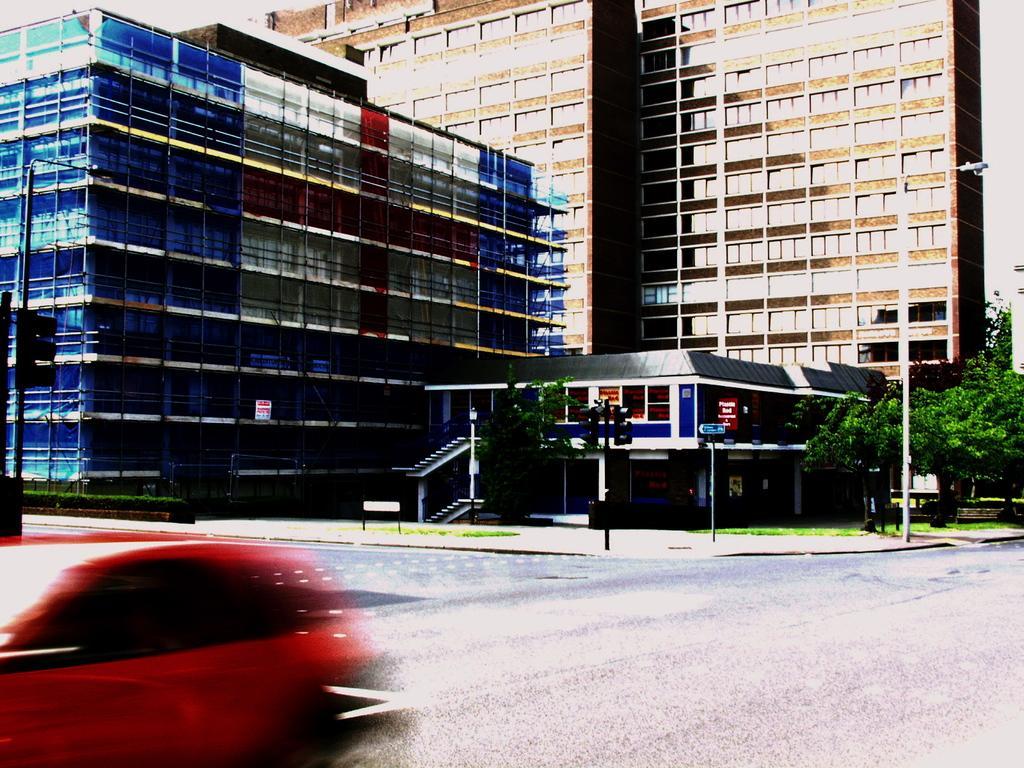Describe this image in one or two sentences. At the bottom of this image I can see a red color car on the road. In the background there are some buildings and trees. Beside the road I can see a traffic signal pole and a street light. 